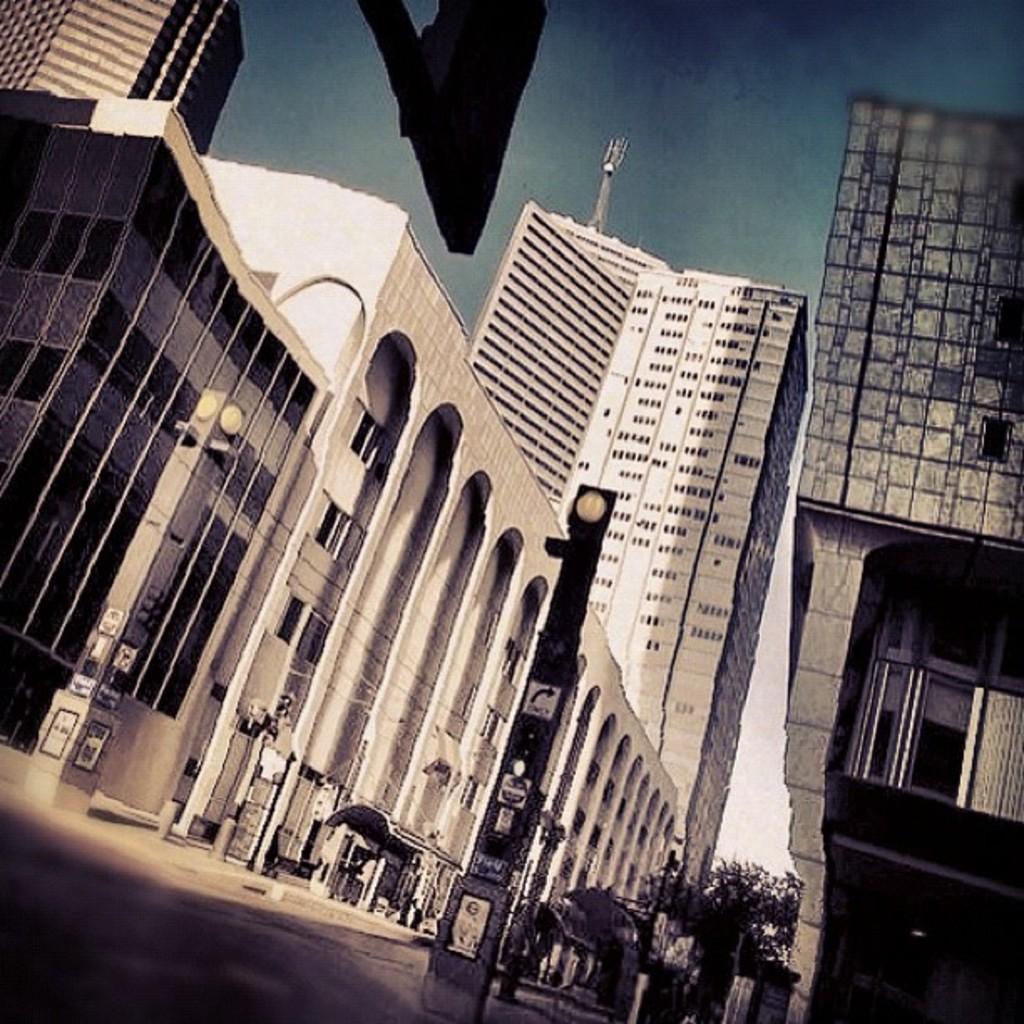In one or two sentences, can you explain what this image depicts? This is an outside view. At the bottom there are poles and some trees on the road. In the background there are many buildings. At the top of the image I can see the sky. 